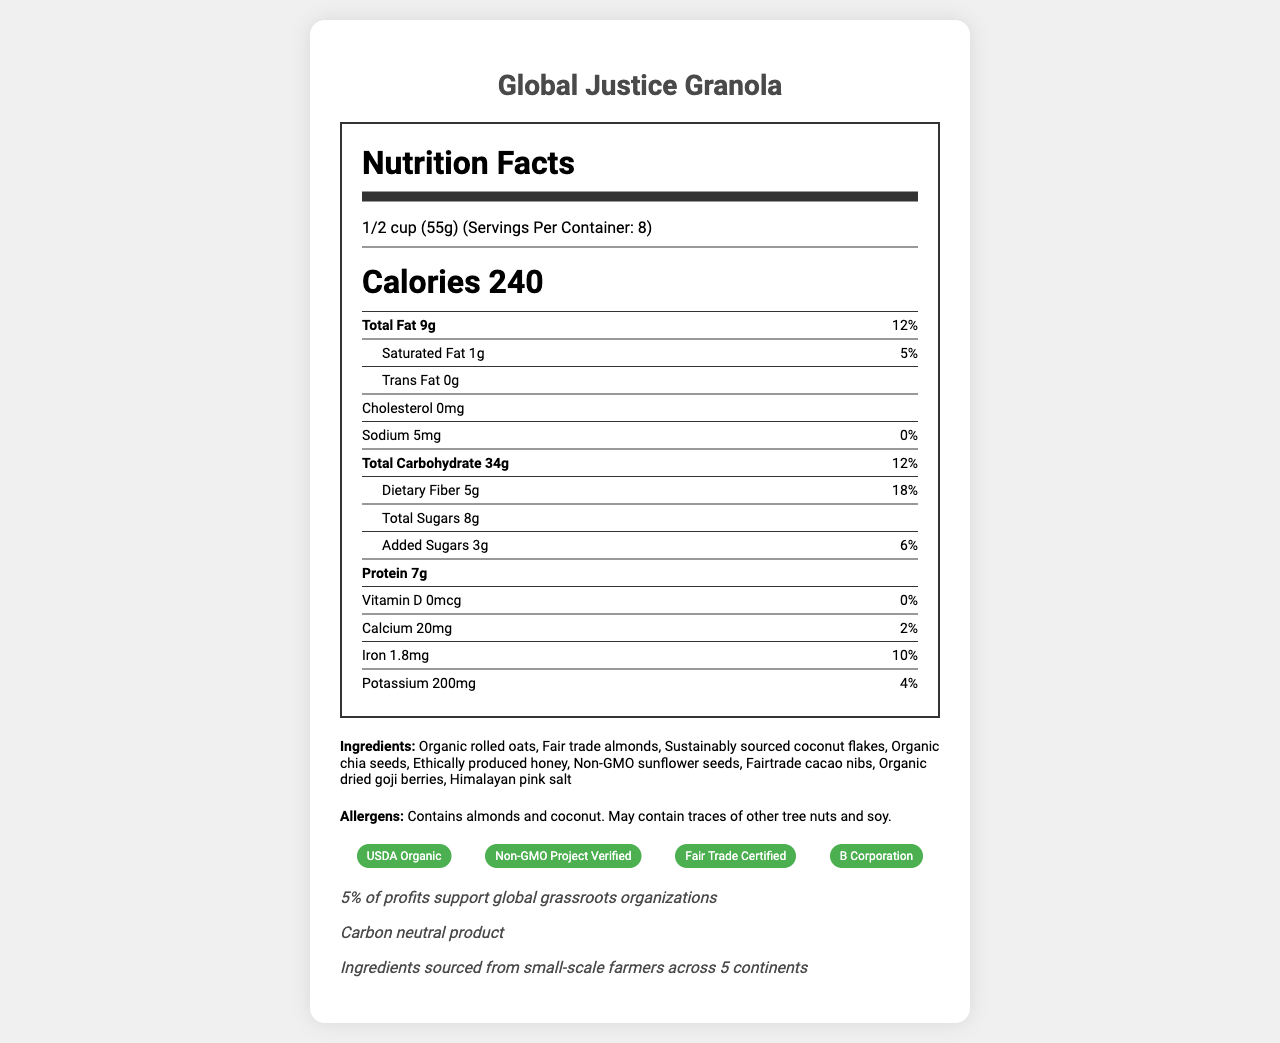Who is the target audience for the Global Justice Granola? The product is described as a trending health food popular among social activists, and it supports global grassroots organizations.
Answer: Social activists What is the serving size for Global Justice Granola? The document indicates that the serving size is 1/2 cup (55g).
Answer: 1/2 cup (55g) How many calories are there per serving? The document states that each serving contains 240 calories.
Answer: 240 calories Which ingredient is included in the Global Justice Granola? One of the listed ingredients is organic rolled oats.
Answer: Organic rolled oats What percentage of the daily value of dietary fiber does one serving contain? The document notes that one serving provides 18% of the daily value for dietary fiber.
Answer: 18% What is one of the certifications listed for the product? The document lists USDA Organic as one of the certifications.
Answer: USDA Organic Which of the following certifications is NOT listed on the document? A. Fair Trade Certified B. Kosher C. B Corporation D. Non-GMO Project Verified The document lists certifications including Fair Trade Certified, B Corporation, and Non-GMO Project Verified, but not Kosher.
Answer: B. Kosher How many grams of protein are there in one serving? The document specifies that one serving contains 7g of protein.
Answer: 7g Which allergen does the product contain? A. Peanuts B. Almonds C. Gluten D. Soy The document specifies that the product contains almonds and coconut, but not peanuts or gluten.
Answer: B. Almonds Is this product carbon-neutral? The document indicates that it is a carbon-neutral product.
Answer: Yes Do the ingredients come from large-scale industrial farms? The document mentions that ingredients are sourced from small-scale farmers across 5 continents.
Answer: No What is unique about the packaging of this product? The document indicates that the packaging is made of 100% recycled and recyclable paperboard.
Answer: 100% recycled and recyclable paperboard Describe the main idea of the document. The document serves to inform consumers about the nutritional content and ethical aspects of the product, emphasizing its certifications, social impact, and environmentally-friendly packaging.
Answer: The document provides detailed nutritional information for a health food product called Global Justice Granola. It highlights the serving size, calories, and nutrient content per serving. It also lists the ingredients, allergens, certifications, packaging, social impact, carbon footprint, and origin of ingredients. Is the method of producing honey listed on the document? While the document mentions "ethically produced honey," specific details about the production method are not provided.
Answer: No What is the daily value percentage of iron in one serving of Global Justice Granola? The document specifies that one serving contains 1.8mg of iron, which is 10% of the daily value.
Answer: 10% Can we determine if the product contains gluten from the document? The document lists some allergens but does not provide information specifically indicating whether the product contains gluten.
Answer: Cannot be determined 